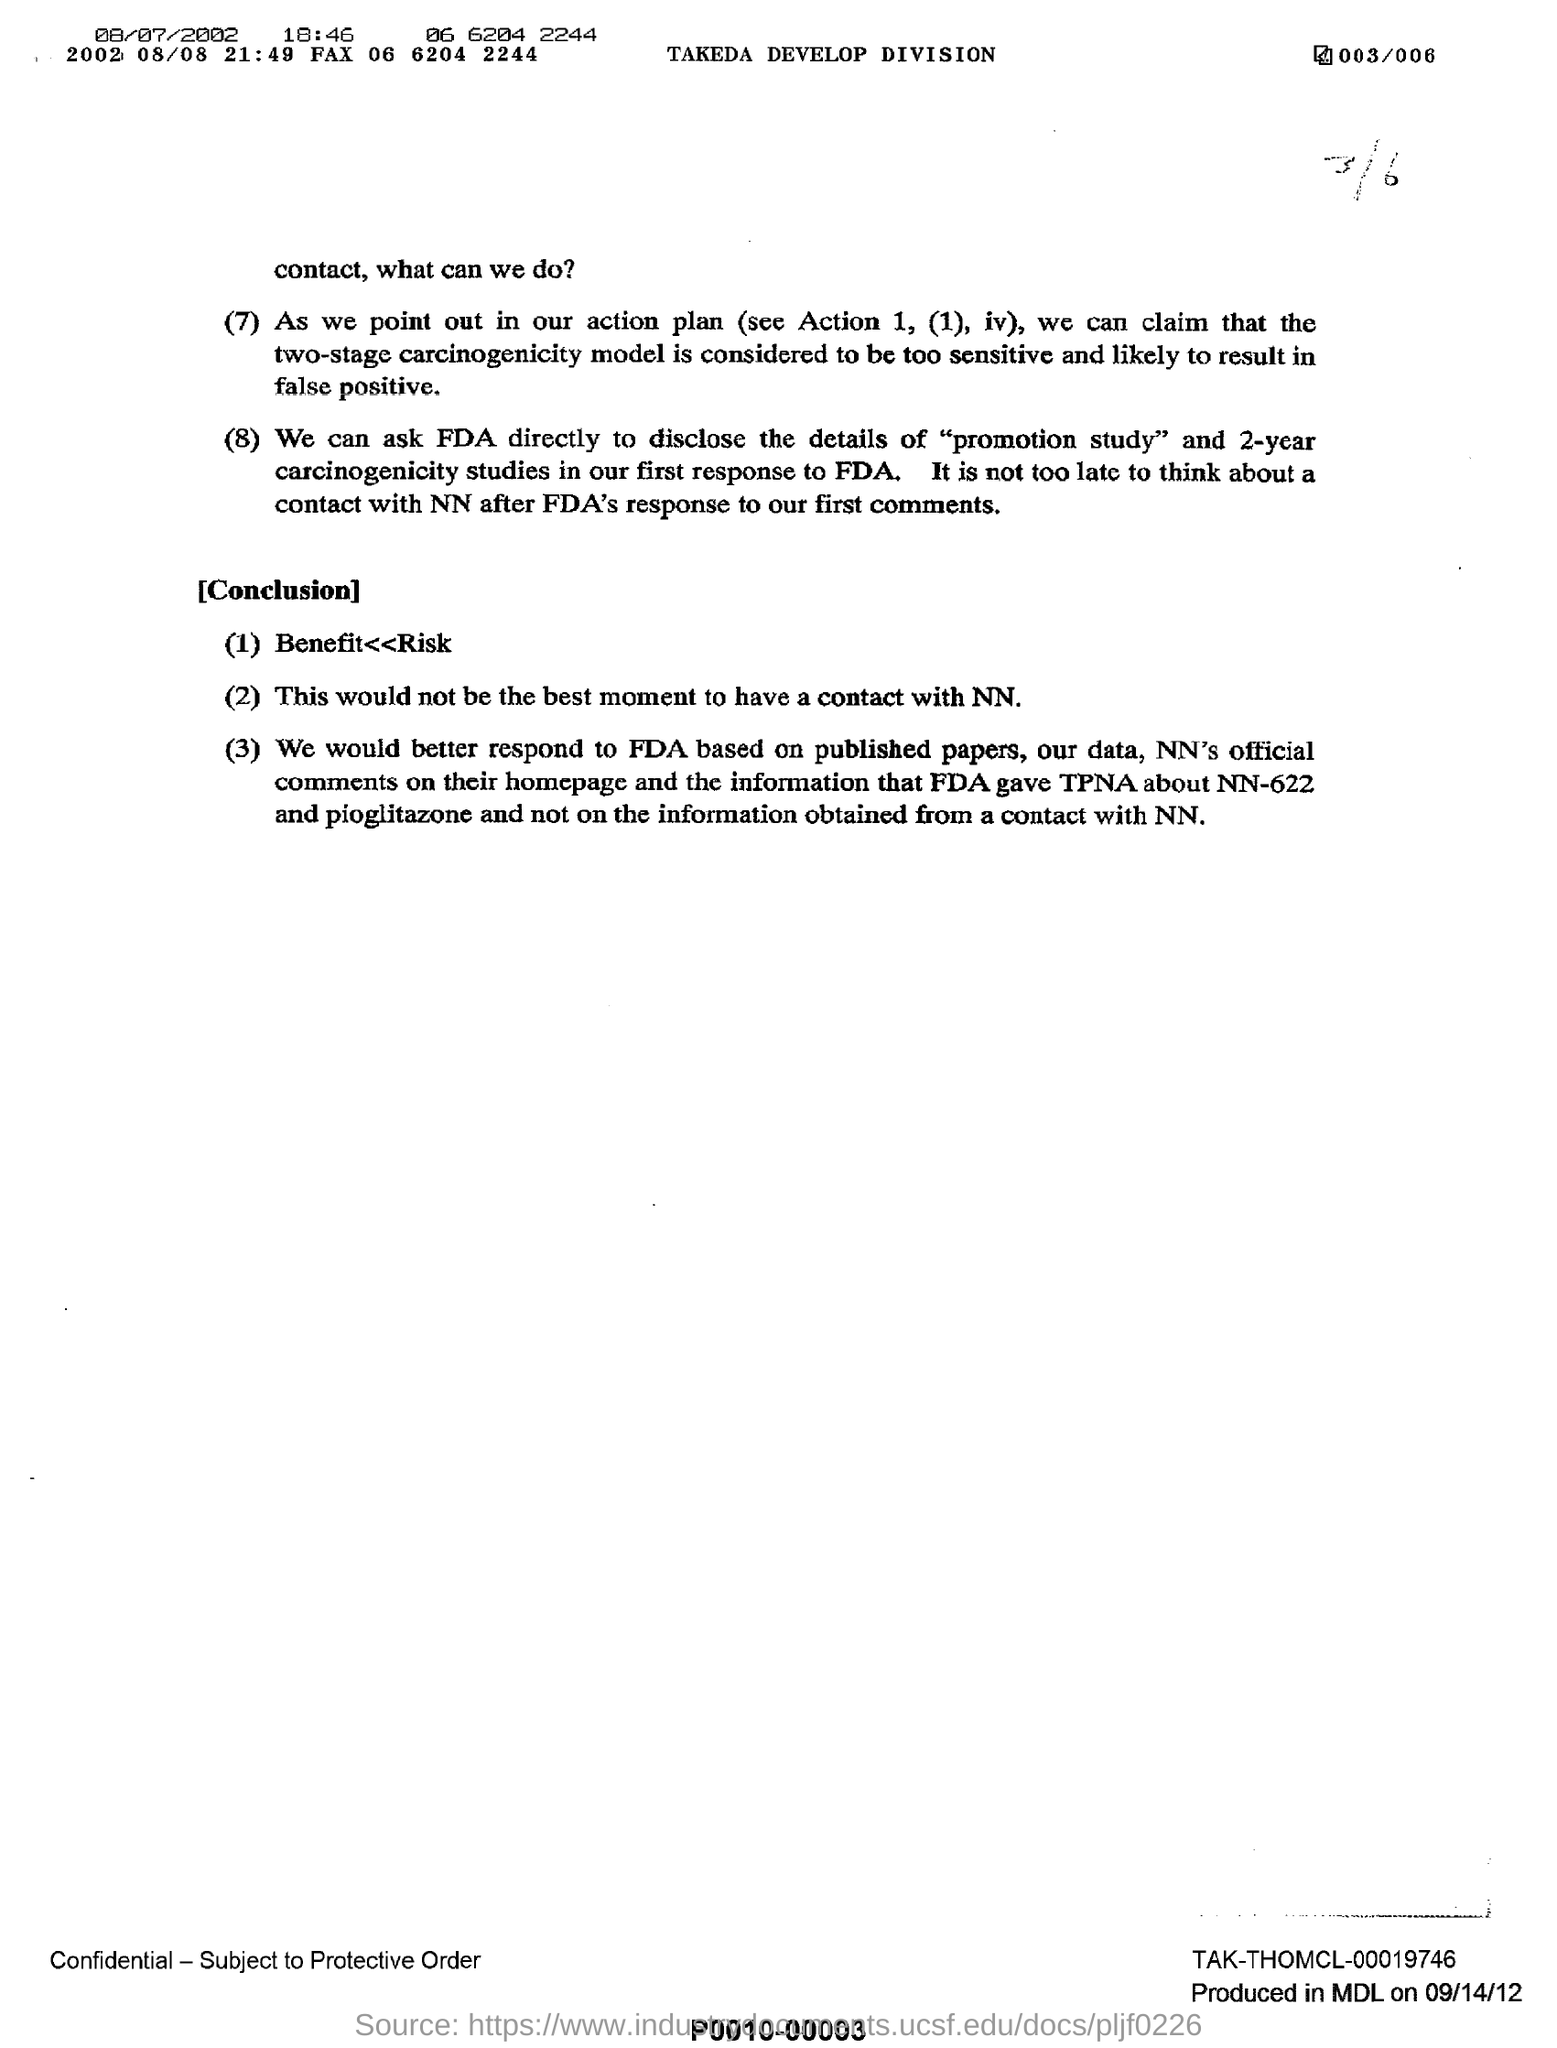What is the fax mentioned ?
Provide a succinct answer. 06 6204 2244. What is year date and time mentioned?
Make the answer very short. 2002 08/08 21:49. What is the name of the division ?
Make the answer very short. Takeda Develop division. To whom they can ask directly to disclose the details of "promotion study"?
Make the answer very short. FDA. 